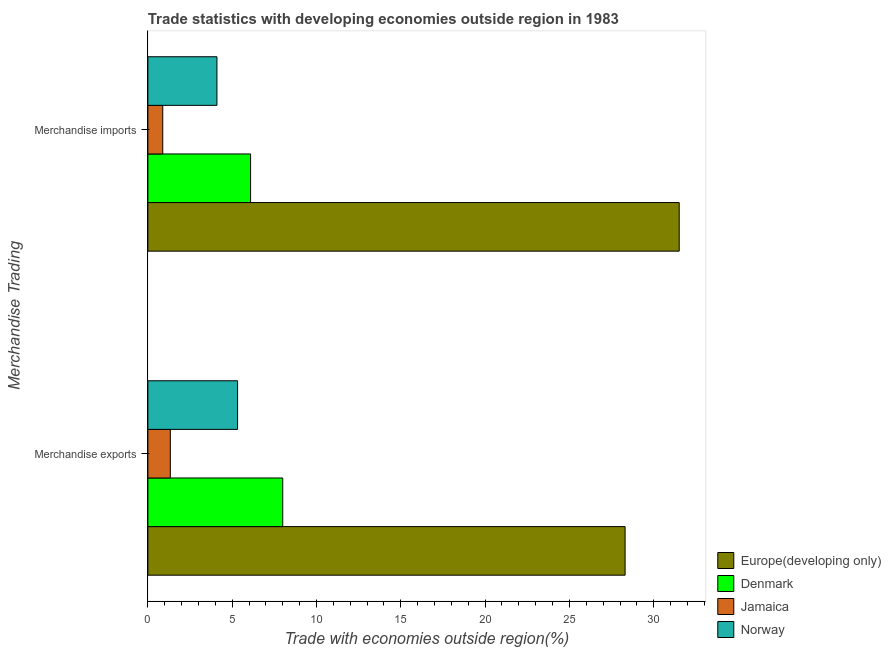How many different coloured bars are there?
Your response must be concise. 4. Are the number of bars on each tick of the Y-axis equal?
Provide a short and direct response. Yes. What is the merchandise imports in Norway?
Ensure brevity in your answer.  4.1. Across all countries, what is the maximum merchandise exports?
Give a very brief answer. 28.3. Across all countries, what is the minimum merchandise exports?
Offer a terse response. 1.33. In which country was the merchandise imports maximum?
Your response must be concise. Europe(developing only). In which country was the merchandise imports minimum?
Your response must be concise. Jamaica. What is the total merchandise exports in the graph?
Your response must be concise. 42.95. What is the difference between the merchandise exports in Jamaica and that in Denmark?
Your answer should be very brief. -6.67. What is the difference between the merchandise exports in Norway and the merchandise imports in Europe(developing only)?
Offer a terse response. -26.19. What is the average merchandise imports per country?
Provide a short and direct response. 10.65. What is the difference between the merchandise exports and merchandise imports in Norway?
Your answer should be compact. 1.22. What is the ratio of the merchandise exports in Jamaica to that in Norway?
Offer a very short reply. 0.25. What does the 4th bar from the top in Merchandise exports represents?
Offer a very short reply. Europe(developing only). What does the 3rd bar from the bottom in Merchandise exports represents?
Offer a very short reply. Jamaica. How many bars are there?
Ensure brevity in your answer.  8. Are all the bars in the graph horizontal?
Provide a succinct answer. Yes. How many countries are there in the graph?
Provide a short and direct response. 4. What is the difference between two consecutive major ticks on the X-axis?
Provide a short and direct response. 5. Does the graph contain grids?
Provide a succinct answer. No. How many legend labels are there?
Your response must be concise. 4. How are the legend labels stacked?
Keep it short and to the point. Vertical. What is the title of the graph?
Give a very brief answer. Trade statistics with developing economies outside region in 1983. What is the label or title of the X-axis?
Your answer should be very brief. Trade with economies outside region(%). What is the label or title of the Y-axis?
Offer a very short reply. Merchandise Trading. What is the Trade with economies outside region(%) of Europe(developing only) in Merchandise exports?
Provide a short and direct response. 28.3. What is the Trade with economies outside region(%) of Denmark in Merchandise exports?
Keep it short and to the point. 8. What is the Trade with economies outside region(%) in Jamaica in Merchandise exports?
Your response must be concise. 1.33. What is the Trade with economies outside region(%) in Norway in Merchandise exports?
Give a very brief answer. 5.32. What is the Trade with economies outside region(%) of Europe(developing only) in Merchandise imports?
Give a very brief answer. 31.51. What is the Trade with economies outside region(%) of Denmark in Merchandise imports?
Give a very brief answer. 6.09. What is the Trade with economies outside region(%) of Jamaica in Merchandise imports?
Make the answer very short. 0.88. What is the Trade with economies outside region(%) of Norway in Merchandise imports?
Give a very brief answer. 4.1. Across all Merchandise Trading, what is the maximum Trade with economies outside region(%) of Europe(developing only)?
Provide a short and direct response. 31.51. Across all Merchandise Trading, what is the maximum Trade with economies outside region(%) of Denmark?
Offer a terse response. 8. Across all Merchandise Trading, what is the maximum Trade with economies outside region(%) of Jamaica?
Offer a very short reply. 1.33. Across all Merchandise Trading, what is the maximum Trade with economies outside region(%) in Norway?
Your answer should be very brief. 5.32. Across all Merchandise Trading, what is the minimum Trade with economies outside region(%) in Europe(developing only)?
Offer a terse response. 28.3. Across all Merchandise Trading, what is the minimum Trade with economies outside region(%) of Denmark?
Ensure brevity in your answer.  6.09. Across all Merchandise Trading, what is the minimum Trade with economies outside region(%) in Jamaica?
Provide a short and direct response. 0.88. Across all Merchandise Trading, what is the minimum Trade with economies outside region(%) of Norway?
Offer a very short reply. 4.1. What is the total Trade with economies outside region(%) of Europe(developing only) in the graph?
Offer a terse response. 59.81. What is the total Trade with economies outside region(%) of Denmark in the graph?
Give a very brief answer. 14.09. What is the total Trade with economies outside region(%) in Jamaica in the graph?
Give a very brief answer. 2.21. What is the total Trade with economies outside region(%) in Norway in the graph?
Ensure brevity in your answer.  9.42. What is the difference between the Trade with economies outside region(%) in Europe(developing only) in Merchandise exports and that in Merchandise imports?
Offer a very short reply. -3.21. What is the difference between the Trade with economies outside region(%) of Denmark in Merchandise exports and that in Merchandise imports?
Provide a succinct answer. 1.91. What is the difference between the Trade with economies outside region(%) in Jamaica in Merchandise exports and that in Merchandise imports?
Give a very brief answer. 0.45. What is the difference between the Trade with economies outside region(%) of Norway in Merchandise exports and that in Merchandise imports?
Offer a very short reply. 1.22. What is the difference between the Trade with economies outside region(%) of Europe(developing only) in Merchandise exports and the Trade with economies outside region(%) of Denmark in Merchandise imports?
Provide a succinct answer. 22.21. What is the difference between the Trade with economies outside region(%) in Europe(developing only) in Merchandise exports and the Trade with economies outside region(%) in Jamaica in Merchandise imports?
Your answer should be compact. 27.42. What is the difference between the Trade with economies outside region(%) of Europe(developing only) in Merchandise exports and the Trade with economies outside region(%) of Norway in Merchandise imports?
Your answer should be compact. 24.21. What is the difference between the Trade with economies outside region(%) in Denmark in Merchandise exports and the Trade with economies outside region(%) in Jamaica in Merchandise imports?
Your answer should be compact. 7.12. What is the difference between the Trade with economies outside region(%) of Denmark in Merchandise exports and the Trade with economies outside region(%) of Norway in Merchandise imports?
Make the answer very short. 3.9. What is the difference between the Trade with economies outside region(%) of Jamaica in Merchandise exports and the Trade with economies outside region(%) of Norway in Merchandise imports?
Your response must be concise. -2.76. What is the average Trade with economies outside region(%) of Europe(developing only) per Merchandise Trading?
Offer a very short reply. 29.91. What is the average Trade with economies outside region(%) in Denmark per Merchandise Trading?
Provide a succinct answer. 7.05. What is the average Trade with economies outside region(%) in Jamaica per Merchandise Trading?
Keep it short and to the point. 1.11. What is the average Trade with economies outside region(%) of Norway per Merchandise Trading?
Offer a terse response. 4.71. What is the difference between the Trade with economies outside region(%) in Europe(developing only) and Trade with economies outside region(%) in Denmark in Merchandise exports?
Your response must be concise. 20.3. What is the difference between the Trade with economies outside region(%) in Europe(developing only) and Trade with economies outside region(%) in Jamaica in Merchandise exports?
Your response must be concise. 26.97. What is the difference between the Trade with economies outside region(%) in Europe(developing only) and Trade with economies outside region(%) in Norway in Merchandise exports?
Provide a succinct answer. 22.98. What is the difference between the Trade with economies outside region(%) of Denmark and Trade with economies outside region(%) of Jamaica in Merchandise exports?
Provide a succinct answer. 6.67. What is the difference between the Trade with economies outside region(%) of Denmark and Trade with economies outside region(%) of Norway in Merchandise exports?
Offer a terse response. 2.68. What is the difference between the Trade with economies outside region(%) of Jamaica and Trade with economies outside region(%) of Norway in Merchandise exports?
Ensure brevity in your answer.  -3.99. What is the difference between the Trade with economies outside region(%) in Europe(developing only) and Trade with economies outside region(%) in Denmark in Merchandise imports?
Offer a terse response. 25.42. What is the difference between the Trade with economies outside region(%) in Europe(developing only) and Trade with economies outside region(%) in Jamaica in Merchandise imports?
Your answer should be very brief. 30.63. What is the difference between the Trade with economies outside region(%) of Europe(developing only) and Trade with economies outside region(%) of Norway in Merchandise imports?
Offer a terse response. 27.42. What is the difference between the Trade with economies outside region(%) of Denmark and Trade with economies outside region(%) of Jamaica in Merchandise imports?
Provide a succinct answer. 5.21. What is the difference between the Trade with economies outside region(%) of Denmark and Trade with economies outside region(%) of Norway in Merchandise imports?
Offer a very short reply. 2. What is the difference between the Trade with economies outside region(%) of Jamaica and Trade with economies outside region(%) of Norway in Merchandise imports?
Keep it short and to the point. -3.21. What is the ratio of the Trade with economies outside region(%) in Europe(developing only) in Merchandise exports to that in Merchandise imports?
Your answer should be compact. 0.9. What is the ratio of the Trade with economies outside region(%) in Denmark in Merchandise exports to that in Merchandise imports?
Offer a terse response. 1.31. What is the ratio of the Trade with economies outside region(%) in Jamaica in Merchandise exports to that in Merchandise imports?
Provide a succinct answer. 1.51. What is the ratio of the Trade with economies outside region(%) in Norway in Merchandise exports to that in Merchandise imports?
Your answer should be very brief. 1.3. What is the difference between the highest and the second highest Trade with economies outside region(%) of Europe(developing only)?
Provide a short and direct response. 3.21. What is the difference between the highest and the second highest Trade with economies outside region(%) of Denmark?
Ensure brevity in your answer.  1.91. What is the difference between the highest and the second highest Trade with economies outside region(%) in Jamaica?
Offer a very short reply. 0.45. What is the difference between the highest and the second highest Trade with economies outside region(%) of Norway?
Give a very brief answer. 1.22. What is the difference between the highest and the lowest Trade with economies outside region(%) in Europe(developing only)?
Your answer should be very brief. 3.21. What is the difference between the highest and the lowest Trade with economies outside region(%) in Denmark?
Offer a very short reply. 1.91. What is the difference between the highest and the lowest Trade with economies outside region(%) in Jamaica?
Your answer should be compact. 0.45. What is the difference between the highest and the lowest Trade with economies outside region(%) in Norway?
Give a very brief answer. 1.22. 